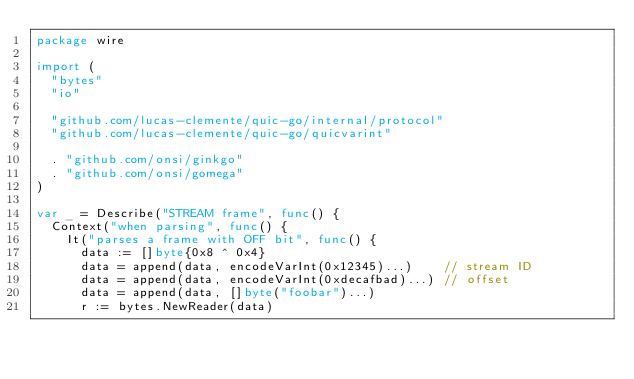Convert code to text. <code><loc_0><loc_0><loc_500><loc_500><_Go_>package wire

import (
	"bytes"
	"io"

	"github.com/lucas-clemente/quic-go/internal/protocol"
	"github.com/lucas-clemente/quic-go/quicvarint"

	. "github.com/onsi/ginkgo"
	. "github.com/onsi/gomega"
)

var _ = Describe("STREAM frame", func() {
	Context("when parsing", func() {
		It("parses a frame with OFF bit", func() {
			data := []byte{0x8 ^ 0x4}
			data = append(data, encodeVarInt(0x12345)...)    // stream ID
			data = append(data, encodeVarInt(0xdecafbad)...) // offset
			data = append(data, []byte("foobar")...)
			r := bytes.NewReader(data)</code> 